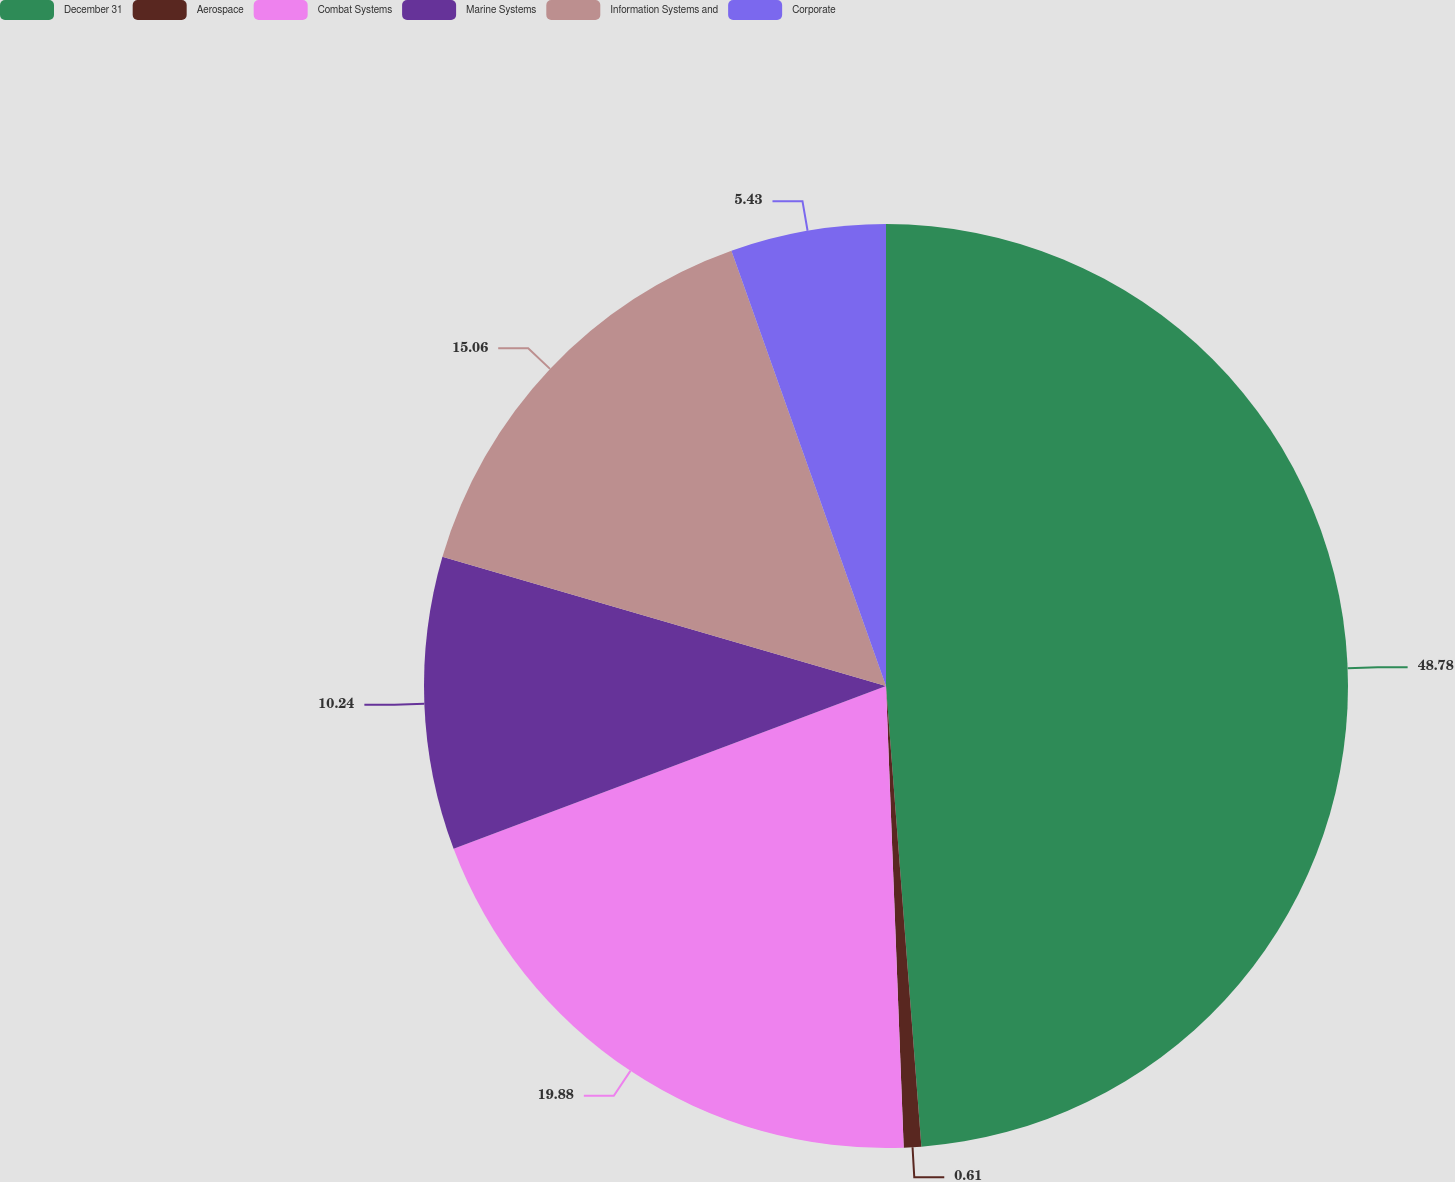<chart> <loc_0><loc_0><loc_500><loc_500><pie_chart><fcel>December 31<fcel>Aerospace<fcel>Combat Systems<fcel>Marine Systems<fcel>Information Systems and<fcel>Corporate<nl><fcel>48.78%<fcel>0.61%<fcel>19.88%<fcel>10.24%<fcel>15.06%<fcel>5.43%<nl></chart> 